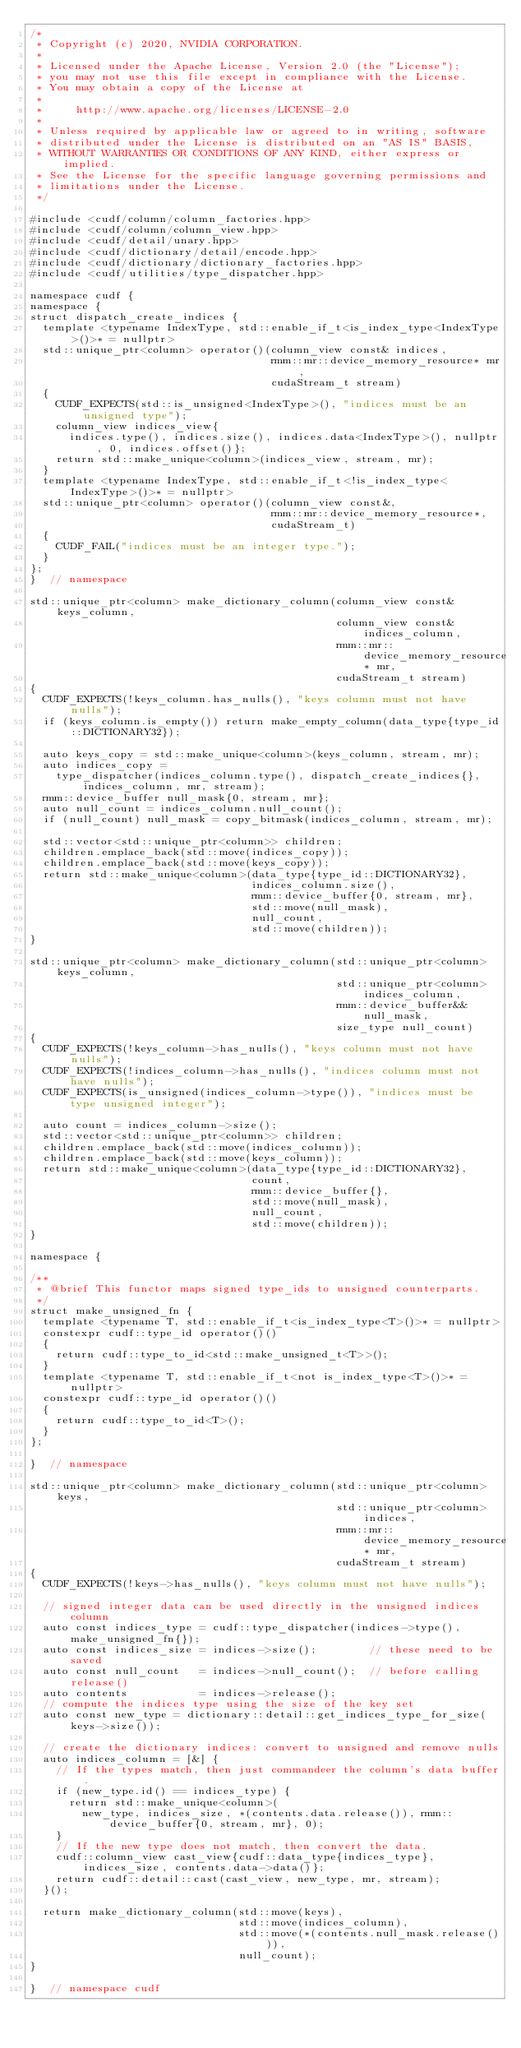Convert code to text. <code><loc_0><loc_0><loc_500><loc_500><_Cuda_>/*
 * Copyright (c) 2020, NVIDIA CORPORATION.
 *
 * Licensed under the Apache License, Version 2.0 (the "License");
 * you may not use this file except in compliance with the License.
 * You may obtain a copy of the License at
 *
 *     http://www.apache.org/licenses/LICENSE-2.0
 *
 * Unless required by applicable law or agreed to in writing, software
 * distributed under the License is distributed on an "AS IS" BASIS,
 * WITHOUT WARRANTIES OR CONDITIONS OF ANY KIND, either express or implied.
 * See the License for the specific language governing permissions and
 * limitations under the License.
 */

#include <cudf/column/column_factories.hpp>
#include <cudf/column/column_view.hpp>
#include <cudf/detail/unary.hpp>
#include <cudf/dictionary/detail/encode.hpp>
#include <cudf/dictionary/dictionary_factories.hpp>
#include <cudf/utilities/type_dispatcher.hpp>

namespace cudf {
namespace {
struct dispatch_create_indices {
  template <typename IndexType, std::enable_if_t<is_index_type<IndexType>()>* = nullptr>
  std::unique_ptr<column> operator()(column_view const& indices,
                                     rmm::mr::device_memory_resource* mr,
                                     cudaStream_t stream)
  {
    CUDF_EXPECTS(std::is_unsigned<IndexType>(), "indices must be an unsigned type");
    column_view indices_view{
      indices.type(), indices.size(), indices.data<IndexType>(), nullptr, 0, indices.offset()};
    return std::make_unique<column>(indices_view, stream, mr);
  }
  template <typename IndexType, std::enable_if_t<!is_index_type<IndexType>()>* = nullptr>
  std::unique_ptr<column> operator()(column_view const&,
                                     rmm::mr::device_memory_resource*,
                                     cudaStream_t)
  {
    CUDF_FAIL("indices must be an integer type.");
  }
};
}  // namespace

std::unique_ptr<column> make_dictionary_column(column_view const& keys_column,
                                               column_view const& indices_column,
                                               rmm::mr::device_memory_resource* mr,
                                               cudaStream_t stream)
{
  CUDF_EXPECTS(!keys_column.has_nulls(), "keys column must not have nulls");
  if (keys_column.is_empty()) return make_empty_column(data_type{type_id::DICTIONARY32});

  auto keys_copy = std::make_unique<column>(keys_column, stream, mr);
  auto indices_copy =
    type_dispatcher(indices_column.type(), dispatch_create_indices{}, indices_column, mr, stream);
  rmm::device_buffer null_mask{0, stream, mr};
  auto null_count = indices_column.null_count();
  if (null_count) null_mask = copy_bitmask(indices_column, stream, mr);

  std::vector<std::unique_ptr<column>> children;
  children.emplace_back(std::move(indices_copy));
  children.emplace_back(std::move(keys_copy));
  return std::make_unique<column>(data_type{type_id::DICTIONARY32},
                                  indices_column.size(),
                                  rmm::device_buffer{0, stream, mr},
                                  std::move(null_mask),
                                  null_count,
                                  std::move(children));
}

std::unique_ptr<column> make_dictionary_column(std::unique_ptr<column> keys_column,
                                               std::unique_ptr<column> indices_column,
                                               rmm::device_buffer&& null_mask,
                                               size_type null_count)
{
  CUDF_EXPECTS(!keys_column->has_nulls(), "keys column must not have nulls");
  CUDF_EXPECTS(!indices_column->has_nulls(), "indices column must not have nulls");
  CUDF_EXPECTS(is_unsigned(indices_column->type()), "indices must be type unsigned integer");

  auto count = indices_column->size();
  std::vector<std::unique_ptr<column>> children;
  children.emplace_back(std::move(indices_column));
  children.emplace_back(std::move(keys_column));
  return std::make_unique<column>(data_type{type_id::DICTIONARY32},
                                  count,
                                  rmm::device_buffer{},
                                  std::move(null_mask),
                                  null_count,
                                  std::move(children));
}

namespace {

/**
 * @brief This functor maps signed type_ids to unsigned counterparts.
 */
struct make_unsigned_fn {
  template <typename T, std::enable_if_t<is_index_type<T>()>* = nullptr>
  constexpr cudf::type_id operator()()
  {
    return cudf::type_to_id<std::make_unsigned_t<T>>();
  }
  template <typename T, std::enable_if_t<not is_index_type<T>()>* = nullptr>
  constexpr cudf::type_id operator()()
  {
    return cudf::type_to_id<T>();
  }
};

}  // namespace

std::unique_ptr<column> make_dictionary_column(std::unique_ptr<column> keys,
                                               std::unique_ptr<column> indices,
                                               rmm::mr::device_memory_resource* mr,
                                               cudaStream_t stream)
{
  CUDF_EXPECTS(!keys->has_nulls(), "keys column must not have nulls");

  // signed integer data can be used directly in the unsigned indices column
  auto const indices_type = cudf::type_dispatcher(indices->type(), make_unsigned_fn{});
  auto const indices_size = indices->size();        // these need to be saved
  auto const null_count   = indices->null_count();  // before calling release()
  auto contents           = indices->release();
  // compute the indices type using the size of the key set
  auto const new_type = dictionary::detail::get_indices_type_for_size(keys->size());

  // create the dictionary indices: convert to unsigned and remove nulls
  auto indices_column = [&] {
    // If the types match, then just commandeer the column's data buffer.
    if (new_type.id() == indices_type) {
      return std::make_unique<column>(
        new_type, indices_size, *(contents.data.release()), rmm::device_buffer{0, stream, mr}, 0);
    }
    // If the new type does not match, then convert the data.
    cudf::column_view cast_view{cudf::data_type{indices_type}, indices_size, contents.data->data()};
    return cudf::detail::cast(cast_view, new_type, mr, stream);
  }();

  return make_dictionary_column(std::move(keys),
                                std::move(indices_column),
                                std::move(*(contents.null_mask.release())),
                                null_count);
}

}  // namespace cudf
</code> 